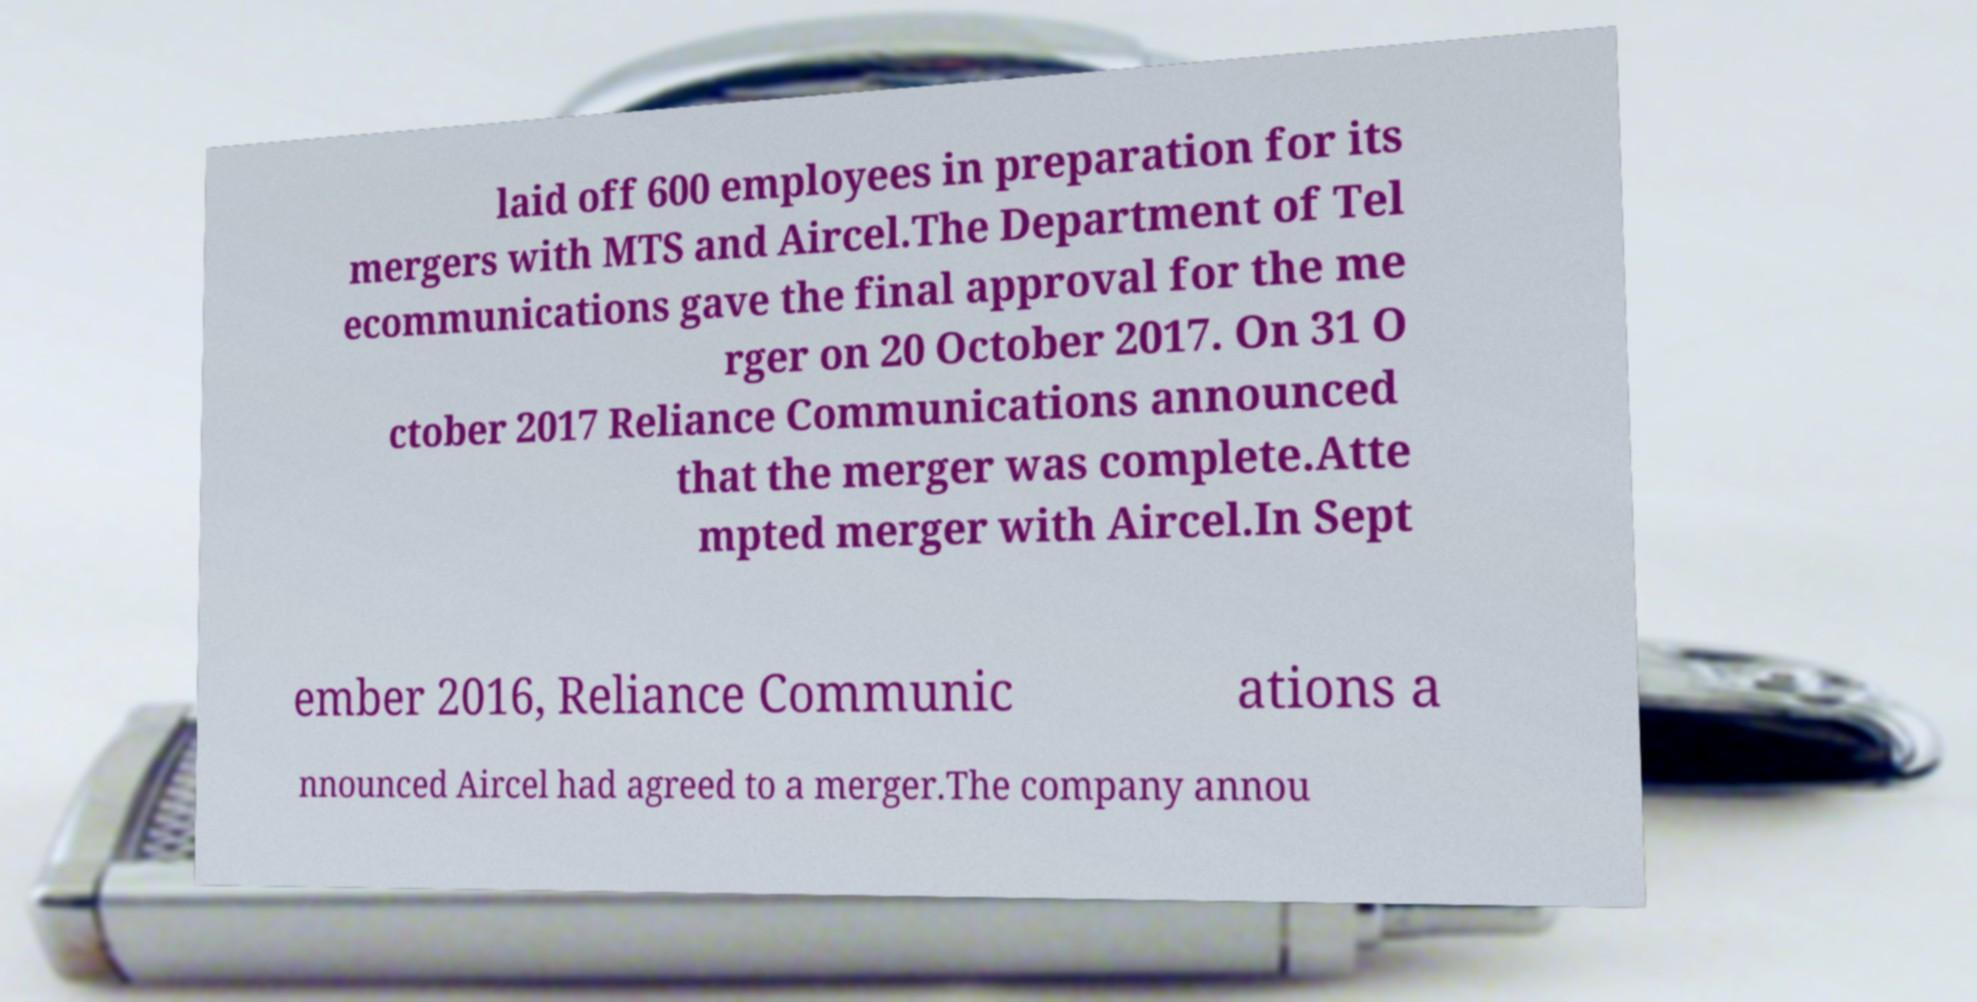Could you extract and type out the text from this image? laid off 600 employees in preparation for its mergers with MTS and Aircel.The Department of Tel ecommunications gave the final approval for the me rger on 20 October 2017. On 31 O ctober 2017 Reliance Communications announced that the merger was complete.Atte mpted merger with Aircel.In Sept ember 2016, Reliance Communic ations a nnounced Aircel had agreed to a merger.The company annou 